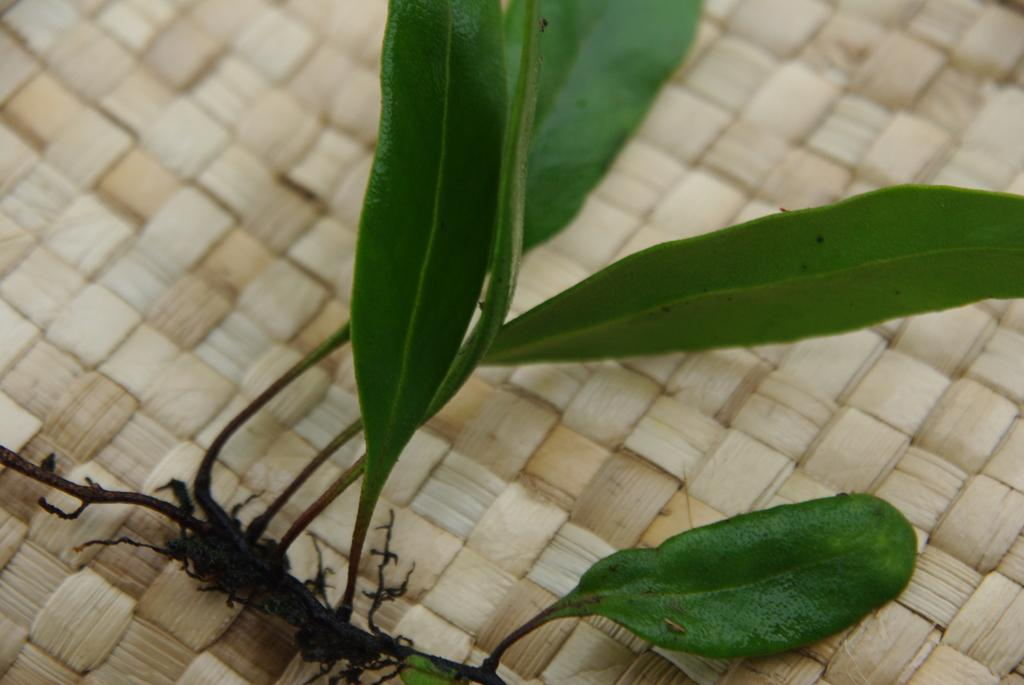What is present in the image? There is a plant in the image. What can be observed about the plant's leaves? The plant has green leaves. On what surface is the plant placed? The plant is placed on a surface. What type of trousers is the plant wearing in the image? Plants do not wear trousers, so this question cannot be answered. 